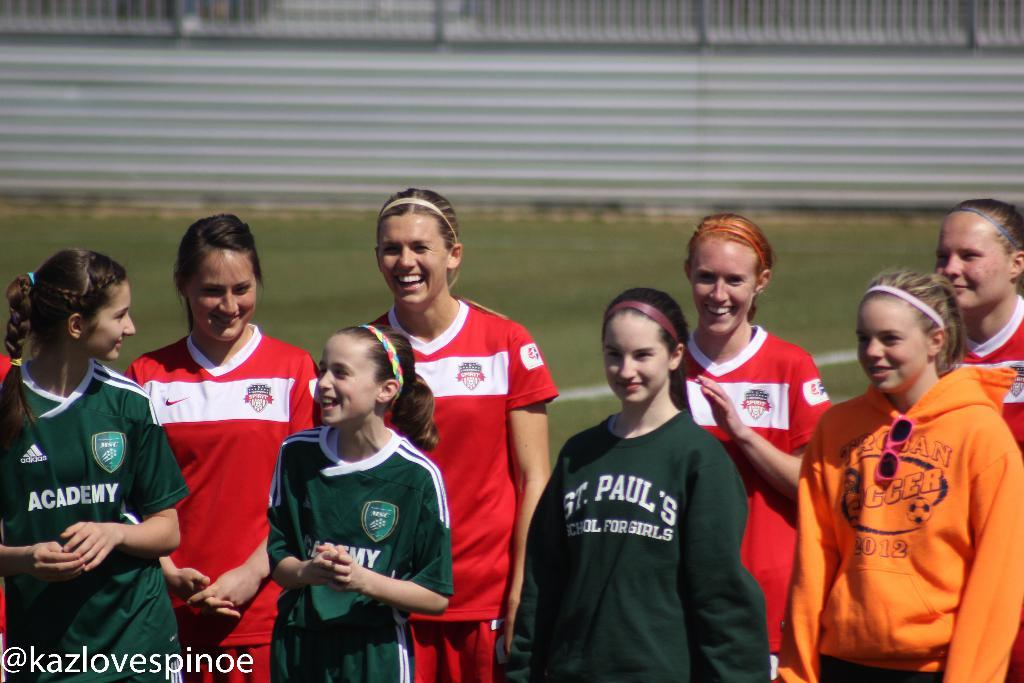What can be seen in the foreground of the image? There are women standing in the foreground of the image. How are the women depicted in the image? The women have smiles on their faces. What type of natural environment is visible in the background of the image? There is grass in the background of the image. What architectural feature can be seen in the background of the image? There is a boundary wall in the wall in the background of the image. What type of pancake is being served to the secretary in the image? There is no pancake or secretary present in the image. Can you describe the breathing pattern of the women in the image? The breathing pattern of the women cannot be determined from the image, as it only shows their facial expressions and not their breathing. 